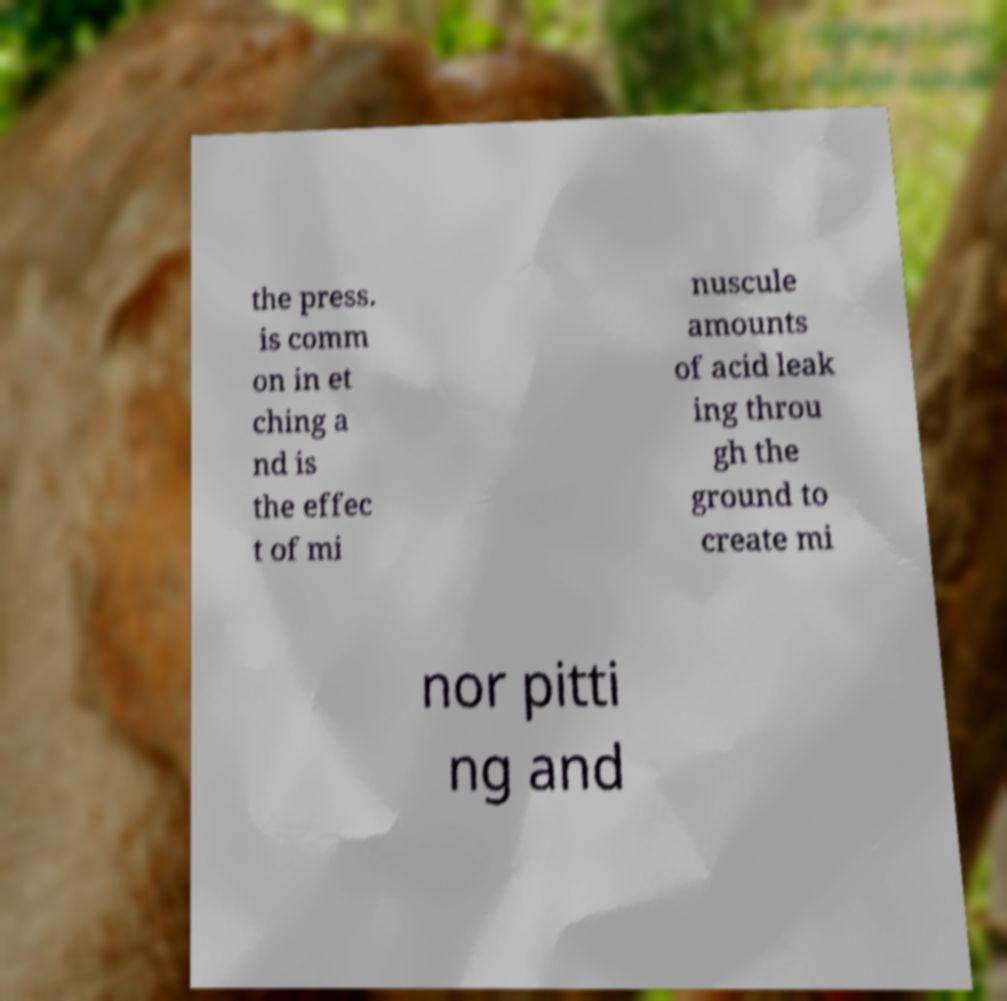Could you assist in decoding the text presented in this image and type it out clearly? the press. is comm on in et ching a nd is the effec t of mi nuscule amounts of acid leak ing throu gh the ground to create mi nor pitti ng and 